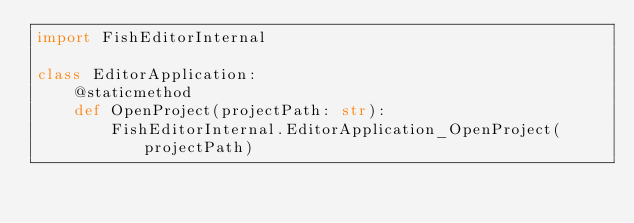<code> <loc_0><loc_0><loc_500><loc_500><_Python_>import FishEditorInternal

class EditorApplication:
    @staticmethod
    def OpenProject(projectPath: str):
        FishEditorInternal.EditorApplication_OpenProject(projectPath)

    </code> 